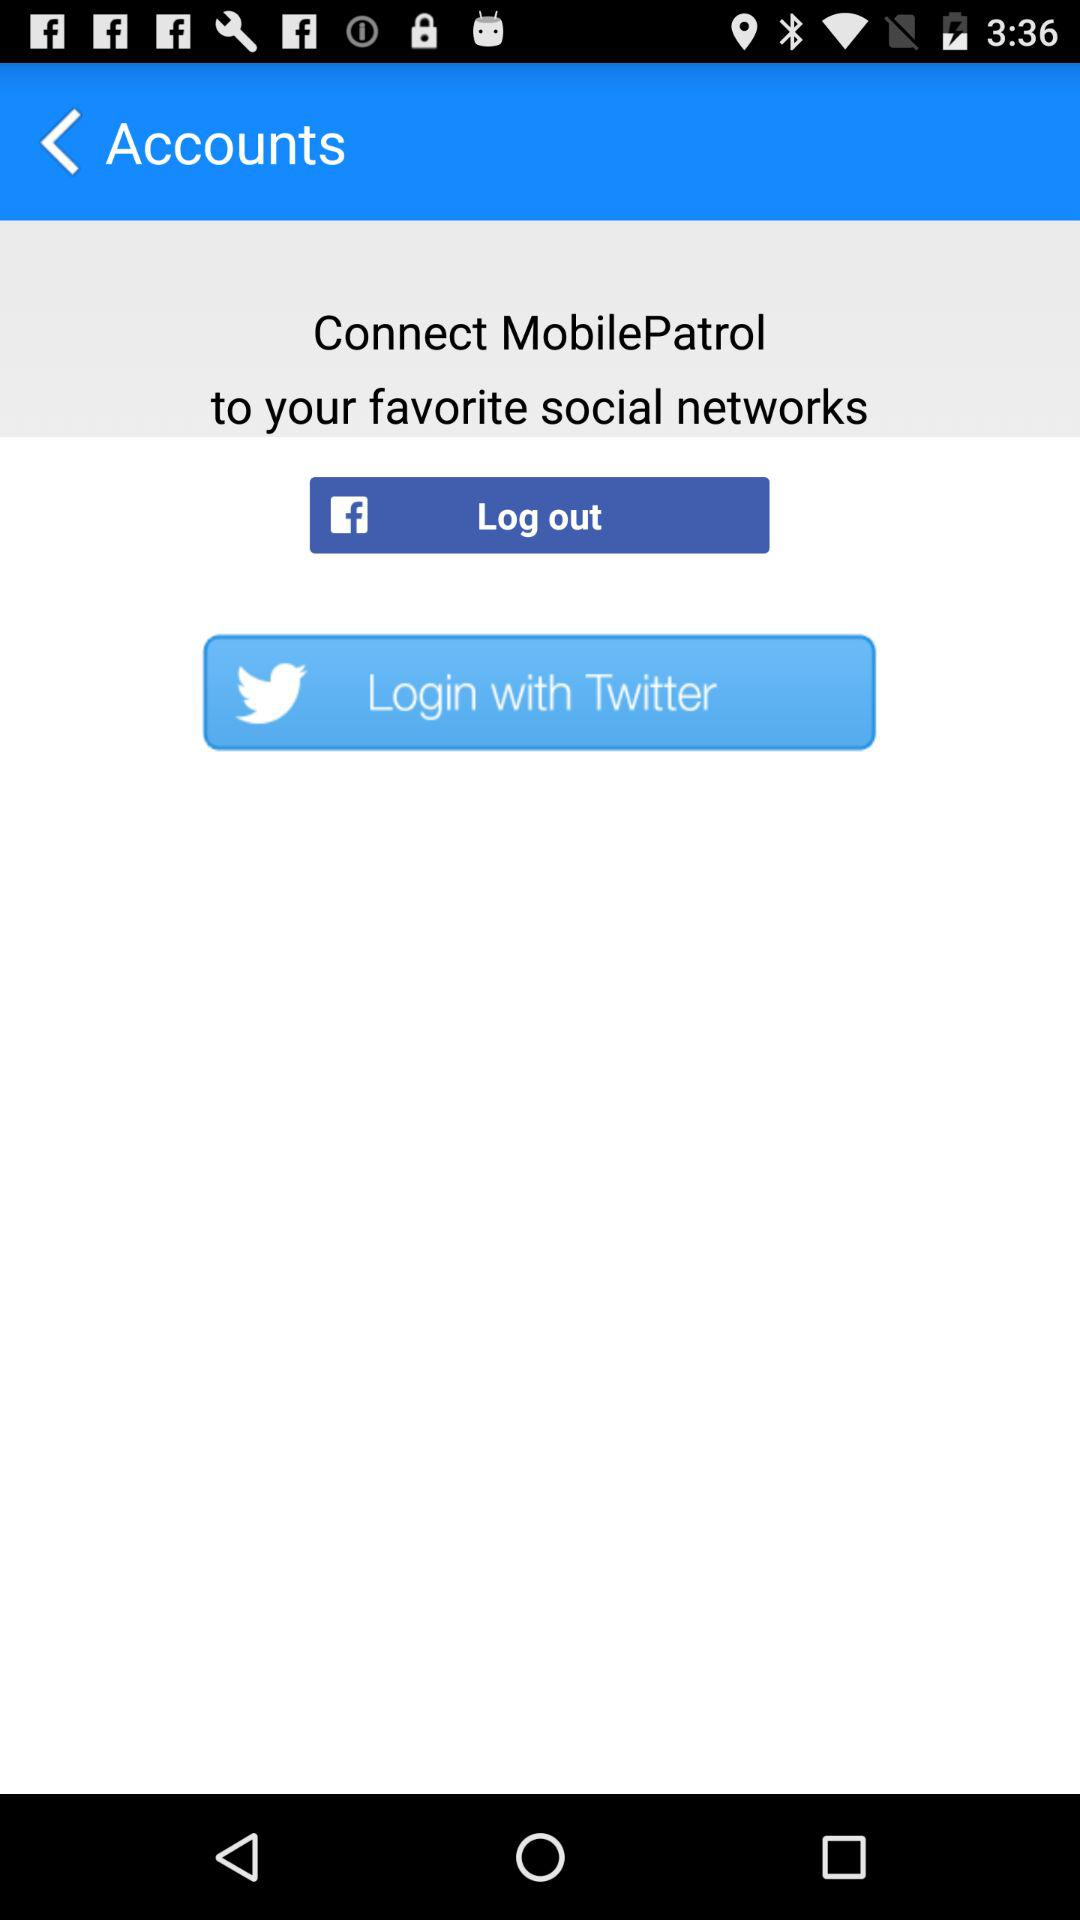What is the name of the application? The name of the application is "MobilePatrol". 